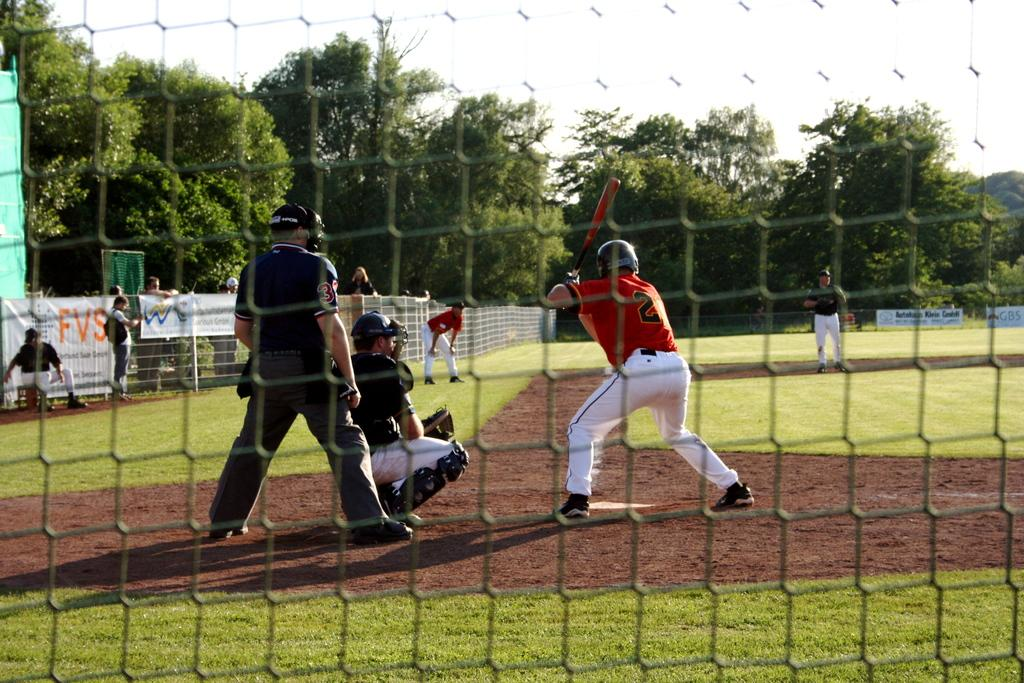<image>
Create a compact narrative representing the image presented. A baseball player with the number 2 on his jersey is up at bat. 